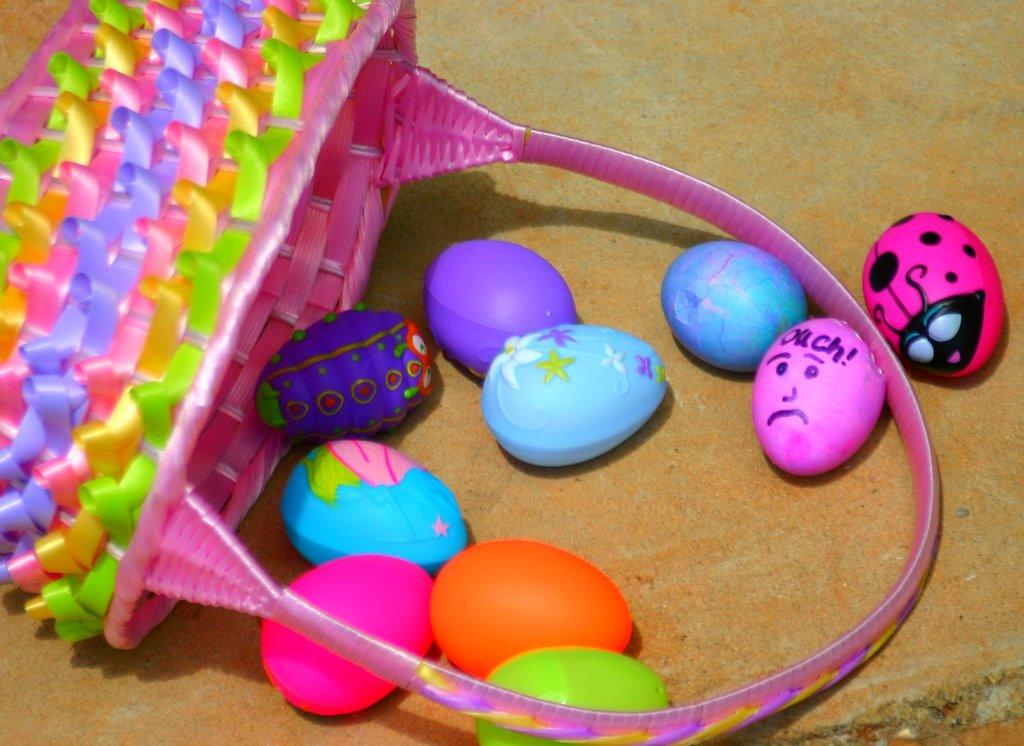What object is present in the image that could be used for carrying items? There is a basket in the image. What type of decorative items can be seen in the image? There are Easter eggs in the image. Where are the basket and Easter eggs located in the image? The basket and Easter eggs are on a wall. How many thumbs can be seen holding the basket in the image? There are no thumbs visible in the image, as the basket and Easter eggs are on a wall. What type of flock is depicted in the image? There is no flock present in the image; it features a basket and Easter eggs on a wall. 